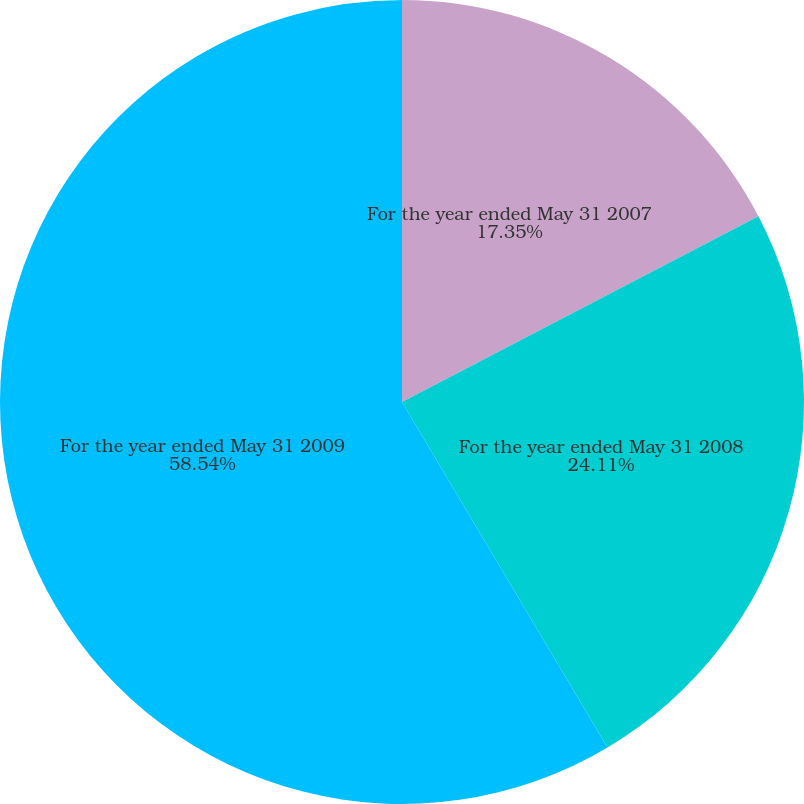Convert chart to OTSL. <chart><loc_0><loc_0><loc_500><loc_500><pie_chart><fcel>For the year ended May 31 2007<fcel>For the year ended May 31 2008<fcel>For the year ended May 31 2009<nl><fcel>17.35%<fcel>24.11%<fcel>58.54%<nl></chart> 